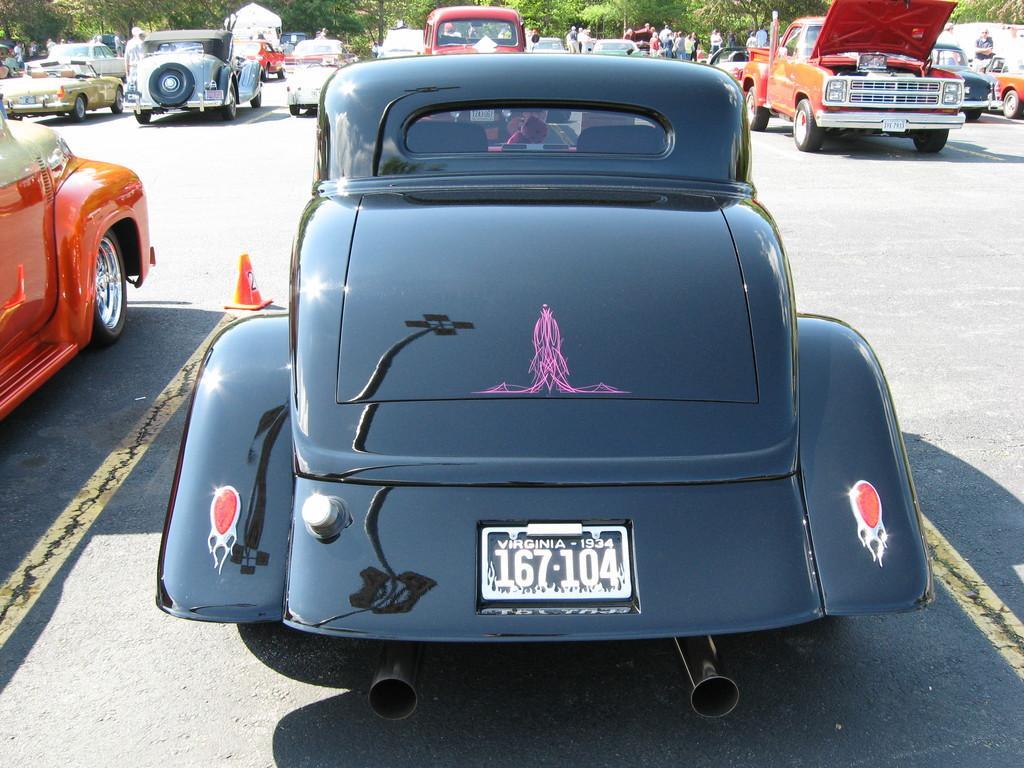How would you summarize this image in a sentence or two? In this image I can see number of cars, an orange colored traffic cone and few people on the road. In the background I can see number of trees and I can also see shadows on the road. 